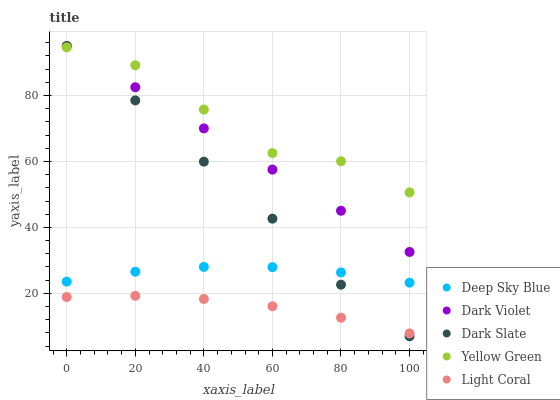Does Light Coral have the minimum area under the curve?
Answer yes or no. Yes. Does Yellow Green have the maximum area under the curve?
Answer yes or no. Yes. Does Dark Slate have the minimum area under the curve?
Answer yes or no. No. Does Dark Slate have the maximum area under the curve?
Answer yes or no. No. Is Dark Violet the smoothest?
Answer yes or no. Yes. Is Yellow Green the roughest?
Answer yes or no. Yes. Is Dark Slate the smoothest?
Answer yes or no. No. Is Dark Slate the roughest?
Answer yes or no. No. Does Dark Slate have the lowest value?
Answer yes or no. Yes. Does Dark Violet have the lowest value?
Answer yes or no. No. Does Dark Violet have the highest value?
Answer yes or no. Yes. Does Deep Sky Blue have the highest value?
Answer yes or no. No. Is Light Coral less than Deep Sky Blue?
Answer yes or no. Yes. Is Deep Sky Blue greater than Light Coral?
Answer yes or no. Yes. Does Dark Slate intersect Light Coral?
Answer yes or no. Yes. Is Dark Slate less than Light Coral?
Answer yes or no. No. Is Dark Slate greater than Light Coral?
Answer yes or no. No. Does Light Coral intersect Deep Sky Blue?
Answer yes or no. No. 